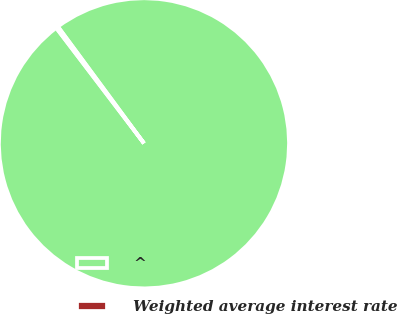<chart> <loc_0><loc_0><loc_500><loc_500><pie_chart><fcel>^<fcel>Weighted average interest rate<nl><fcel>99.76%<fcel>0.24%<nl></chart> 